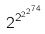<formula> <loc_0><loc_0><loc_500><loc_500>2 ^ { 2 ^ { 2 ^ { 2 ^ { 7 4 } } } }</formula> 